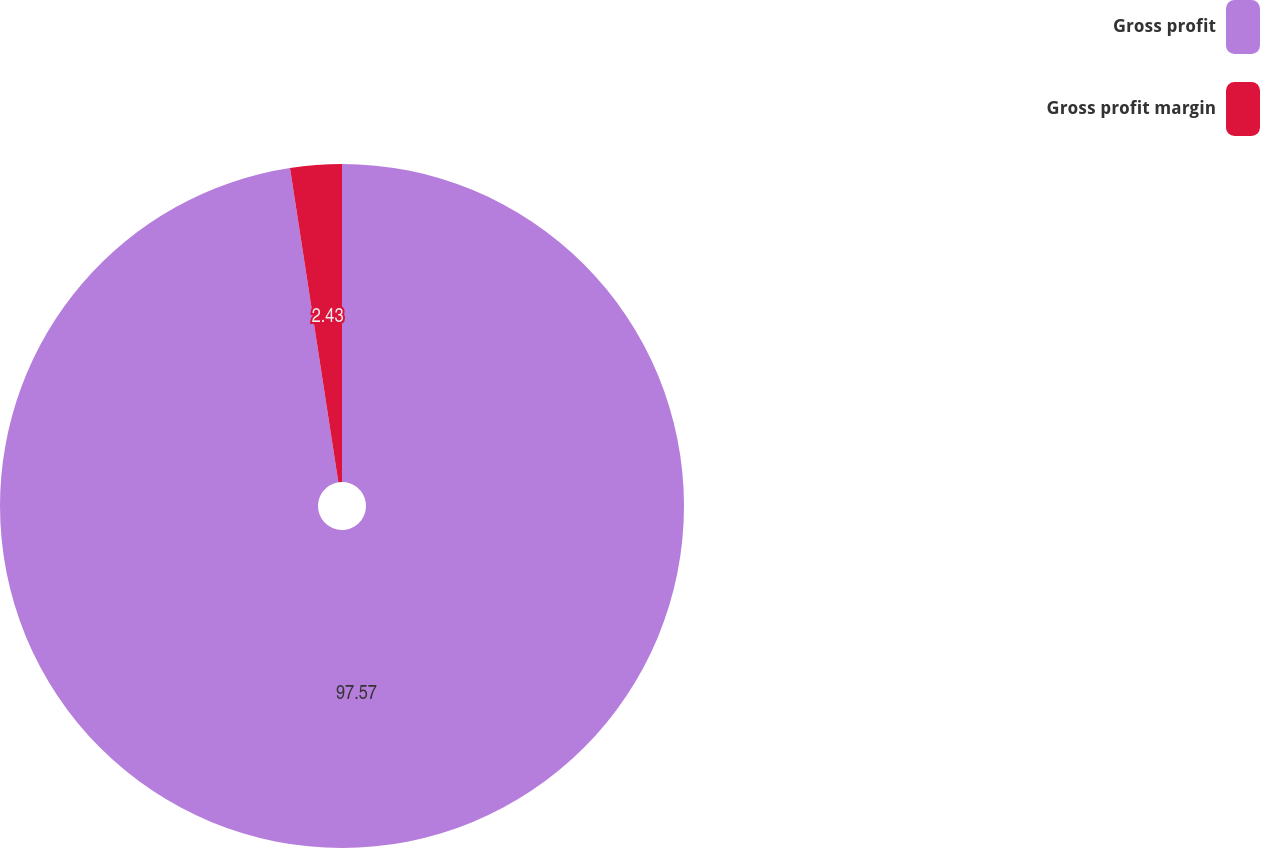Convert chart. <chart><loc_0><loc_0><loc_500><loc_500><pie_chart><fcel>Gross profit<fcel>Gross profit margin<nl><fcel>97.57%<fcel>2.43%<nl></chart> 